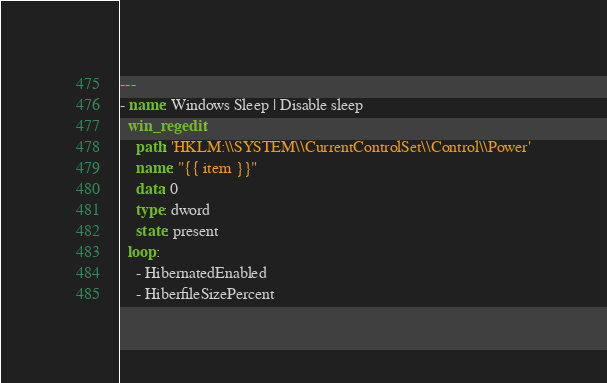Convert code to text. <code><loc_0><loc_0><loc_500><loc_500><_YAML_>---
- name: Windows Sleep | Disable sleep
  win_regedit:
    path: 'HKLM:\\SYSTEM\\CurrentControlSet\\Control\\Power'
    name: "{{ item }}"
    data: 0
    type: dword
    state: present
  loop:
    - HibernatedEnabled
    - HiberfileSizePercent
</code> 